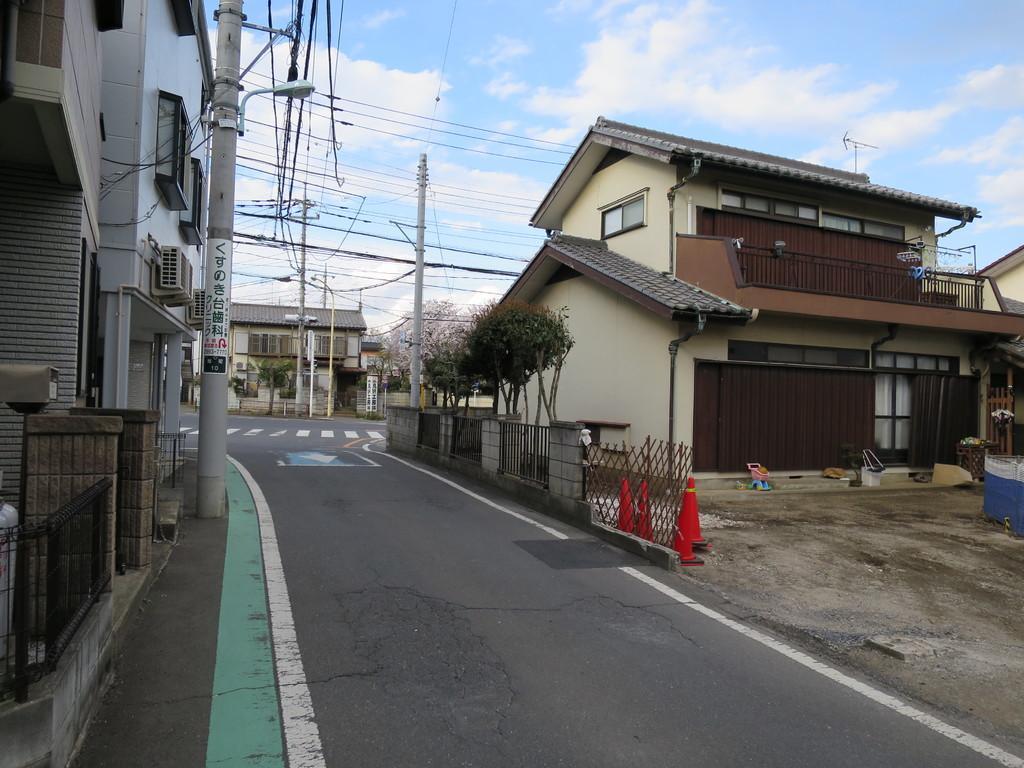Could you give a brief overview of what you see in this image? In this picture there are buildings on the left side of the image and there are houses on the right and in the center of the image, there are plants and traffic cones in the center of the image and there are poles on the left and in the center of the image, there are wires at the top side of the image. 